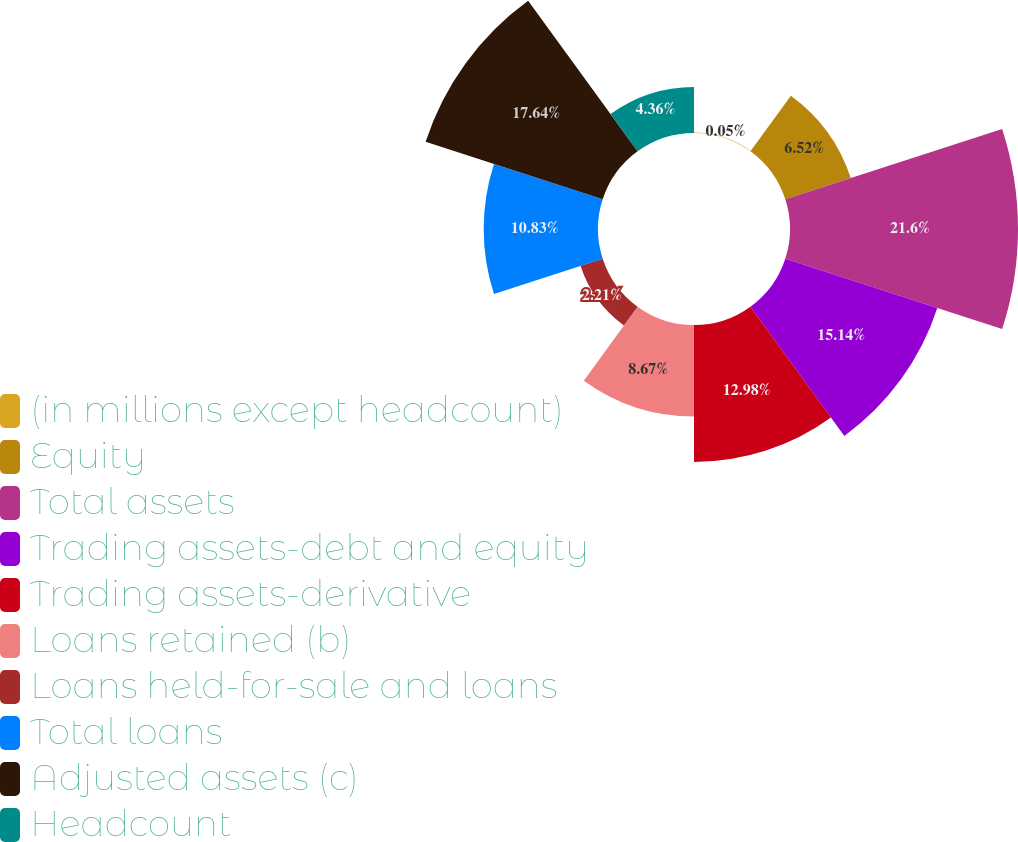<chart> <loc_0><loc_0><loc_500><loc_500><pie_chart><fcel>(in millions except headcount)<fcel>Equity<fcel>Total assets<fcel>Trading assets-debt and equity<fcel>Trading assets-derivative<fcel>Loans retained (b)<fcel>Loans held-for-sale and loans<fcel>Total loans<fcel>Adjusted assets (c)<fcel>Headcount<nl><fcel>0.05%<fcel>6.52%<fcel>21.6%<fcel>15.14%<fcel>12.98%<fcel>8.67%<fcel>2.21%<fcel>10.83%<fcel>17.64%<fcel>4.36%<nl></chart> 